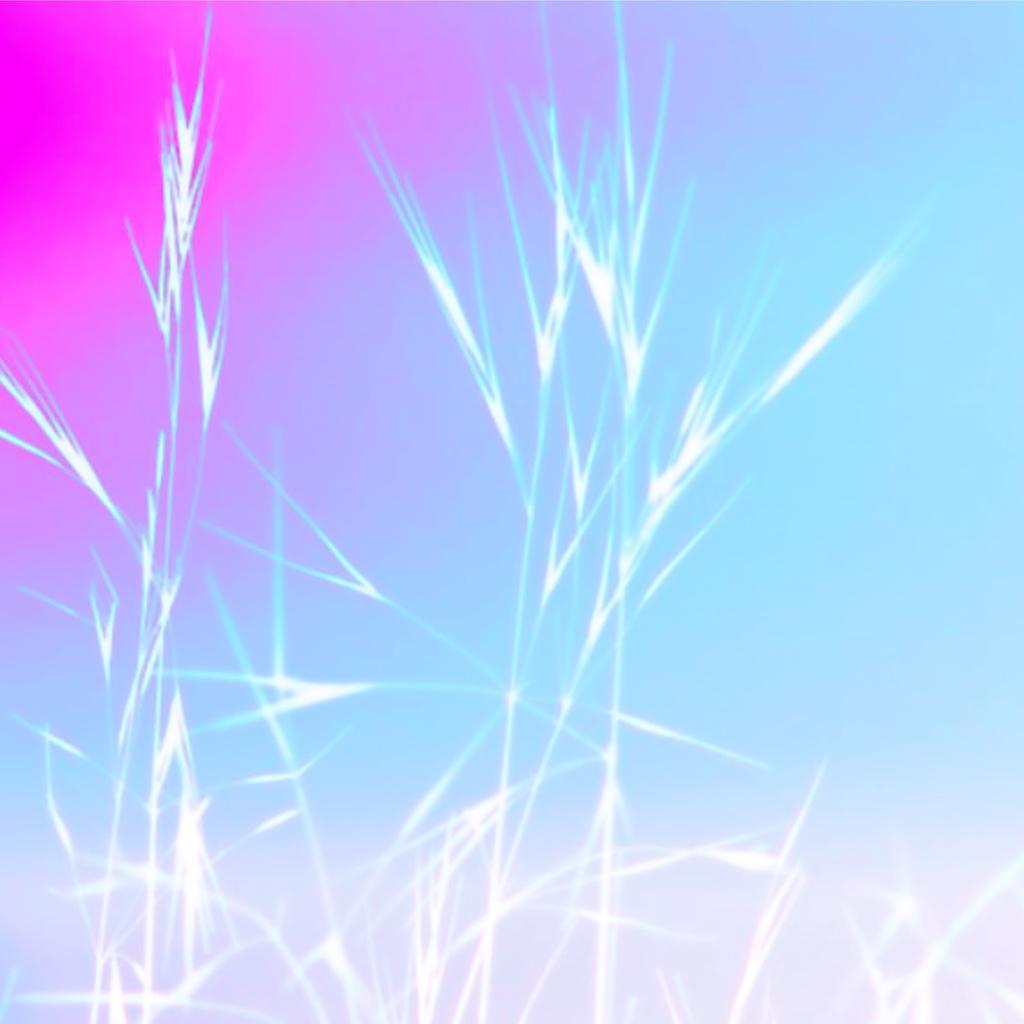Please provide a concise description of this image. In this image there is grass, there is a blue background behind the grass, there is pink background behind the grass. 